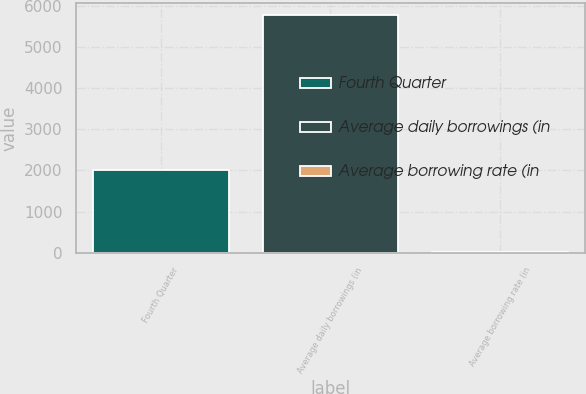Convert chart to OTSL. <chart><loc_0><loc_0><loc_500><loc_500><bar_chart><fcel>Fourth Quarter<fcel>Average daily borrowings (in<fcel>Average borrowing rate (in<nl><fcel>2016<fcel>5779<fcel>6.9<nl></chart> 